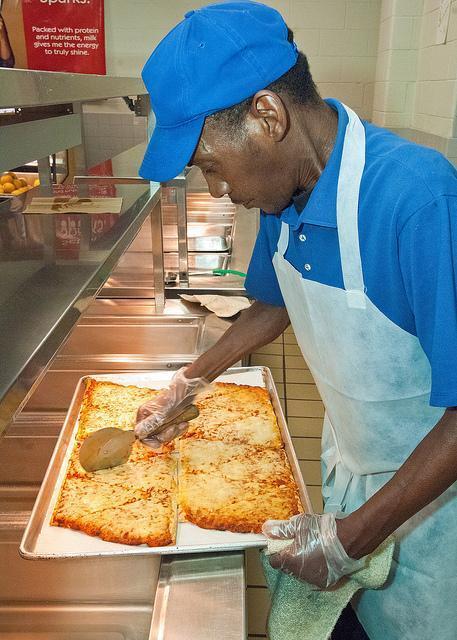How many pizzas are there?
Give a very brief answer. 4. 